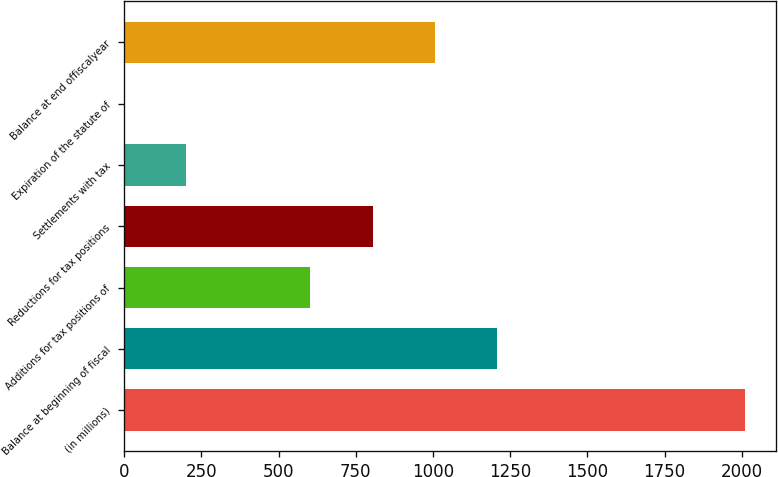Convert chart. <chart><loc_0><loc_0><loc_500><loc_500><bar_chart><fcel>(in millions)<fcel>Balance at beginning of fiscal<fcel>Additions for tax positions of<fcel>Reductions for tax positions<fcel>Settlements with tax<fcel>Expiration of the statute of<fcel>Balance at end offiscalyear<nl><fcel>2010<fcel>1206.24<fcel>603.42<fcel>804.36<fcel>201.54<fcel>0.6<fcel>1005.3<nl></chart> 